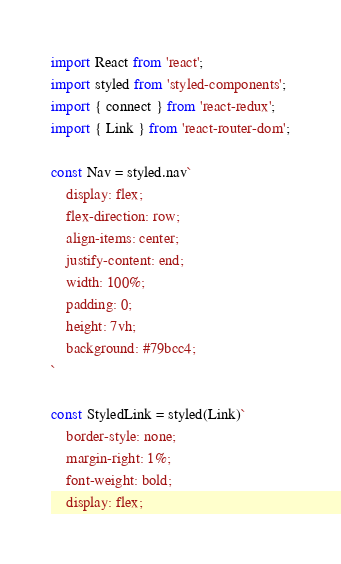Convert code to text. <code><loc_0><loc_0><loc_500><loc_500><_JavaScript_>import React from 'react';
import styled from 'styled-components';
import { connect } from 'react-redux';
import { Link } from 'react-router-dom';

const Nav = styled.nav`
    display: flex;
    flex-direction: row;
    align-items: center;
    justify-content: end;
    width: 100%;
    padding: 0;
    height: 7vh;
    background: #79bcc4;
`

const StyledLink = styled(Link)`
    border-style: none;
    margin-right: 1%;
    font-weight: bold;
    display: flex;</code> 